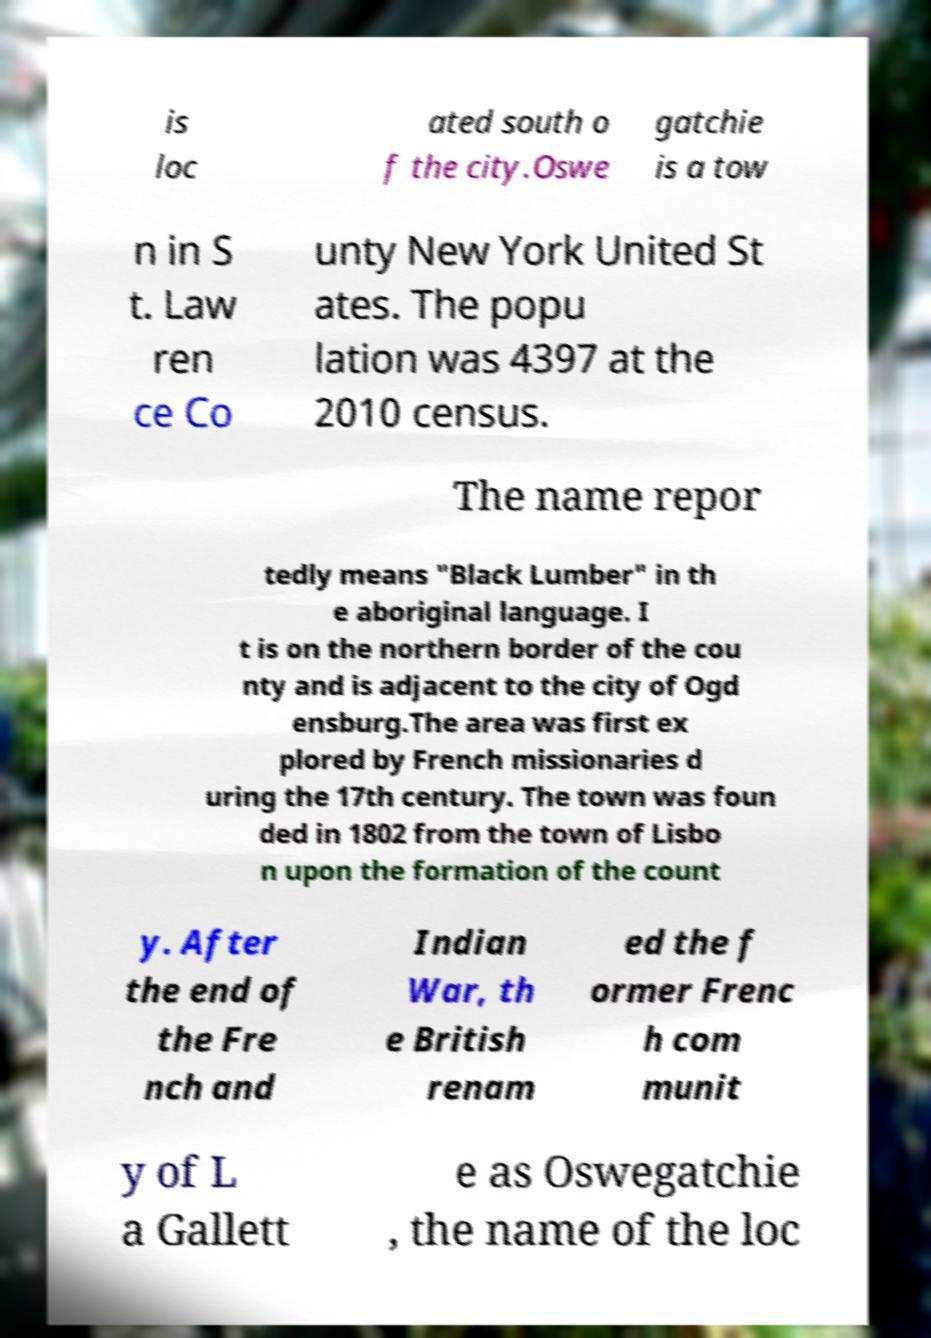Could you extract and type out the text from this image? is loc ated south o f the city.Oswe gatchie is a tow n in S t. Law ren ce Co unty New York United St ates. The popu lation was 4397 at the 2010 census. The name repor tedly means "Black Lumber" in th e aboriginal language. I t is on the northern border of the cou nty and is adjacent to the city of Ogd ensburg.The area was first ex plored by French missionaries d uring the 17th century. The town was foun ded in 1802 from the town of Lisbo n upon the formation of the count y. After the end of the Fre nch and Indian War, th e British renam ed the f ormer Frenc h com munit y of L a Gallett e as Oswegatchie , the name of the loc 